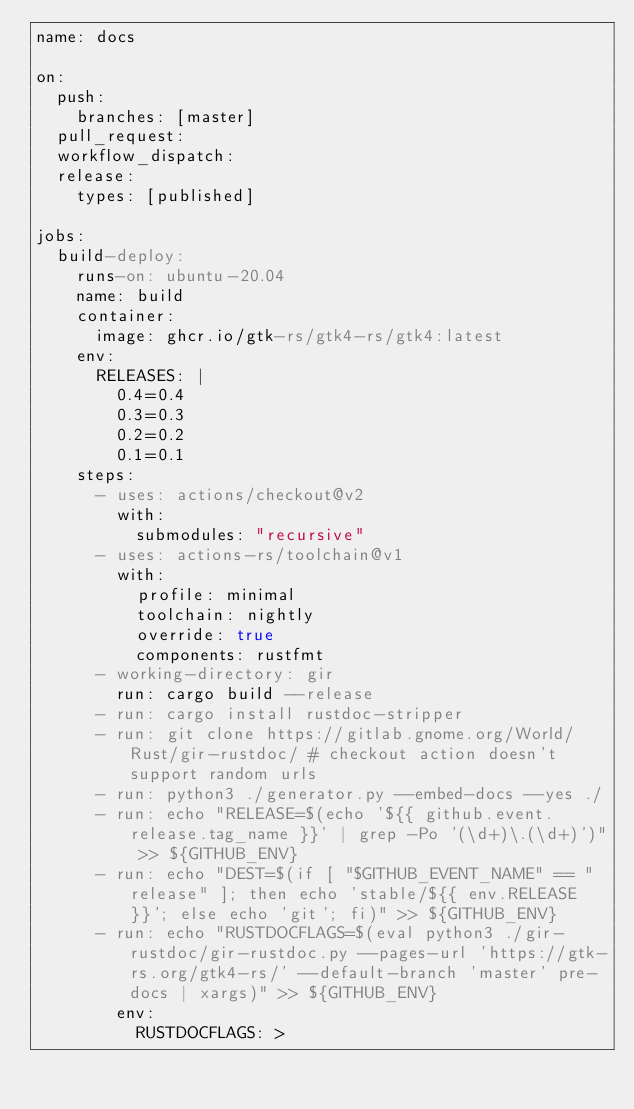<code> <loc_0><loc_0><loc_500><loc_500><_YAML_>name: docs

on:
  push:
    branches: [master]
  pull_request:
  workflow_dispatch:
  release:
    types: [published]

jobs:
  build-deploy:
    runs-on: ubuntu-20.04
    name: build
    container:
      image: ghcr.io/gtk-rs/gtk4-rs/gtk4:latest
    env:
      RELEASES: |
        0.4=0.4
        0.3=0.3
        0.2=0.2
        0.1=0.1
    steps:
      - uses: actions/checkout@v2
        with:
          submodules: "recursive"
      - uses: actions-rs/toolchain@v1
        with:
          profile: minimal
          toolchain: nightly
          override: true
          components: rustfmt
      - working-directory: gir
        run: cargo build --release
      - run: cargo install rustdoc-stripper
      - run: git clone https://gitlab.gnome.org/World/Rust/gir-rustdoc/ # checkout action doesn't support random urls
      - run: python3 ./generator.py --embed-docs --yes ./
      - run: echo "RELEASE=$(echo '${{ github.event.release.tag_name }}' | grep -Po '(\d+)\.(\d+)')" >> ${GITHUB_ENV}
      - run: echo "DEST=$(if [ "$GITHUB_EVENT_NAME" == "release" ]; then echo 'stable/${{ env.RELEASE }}'; else echo 'git'; fi)" >> ${GITHUB_ENV}
      - run: echo "RUSTDOCFLAGS=$(eval python3 ./gir-rustdoc/gir-rustdoc.py --pages-url 'https://gtk-rs.org/gtk4-rs/' --default-branch 'master' pre-docs | xargs)" >> ${GITHUB_ENV}
        env:
          RUSTDOCFLAGS: ></code> 